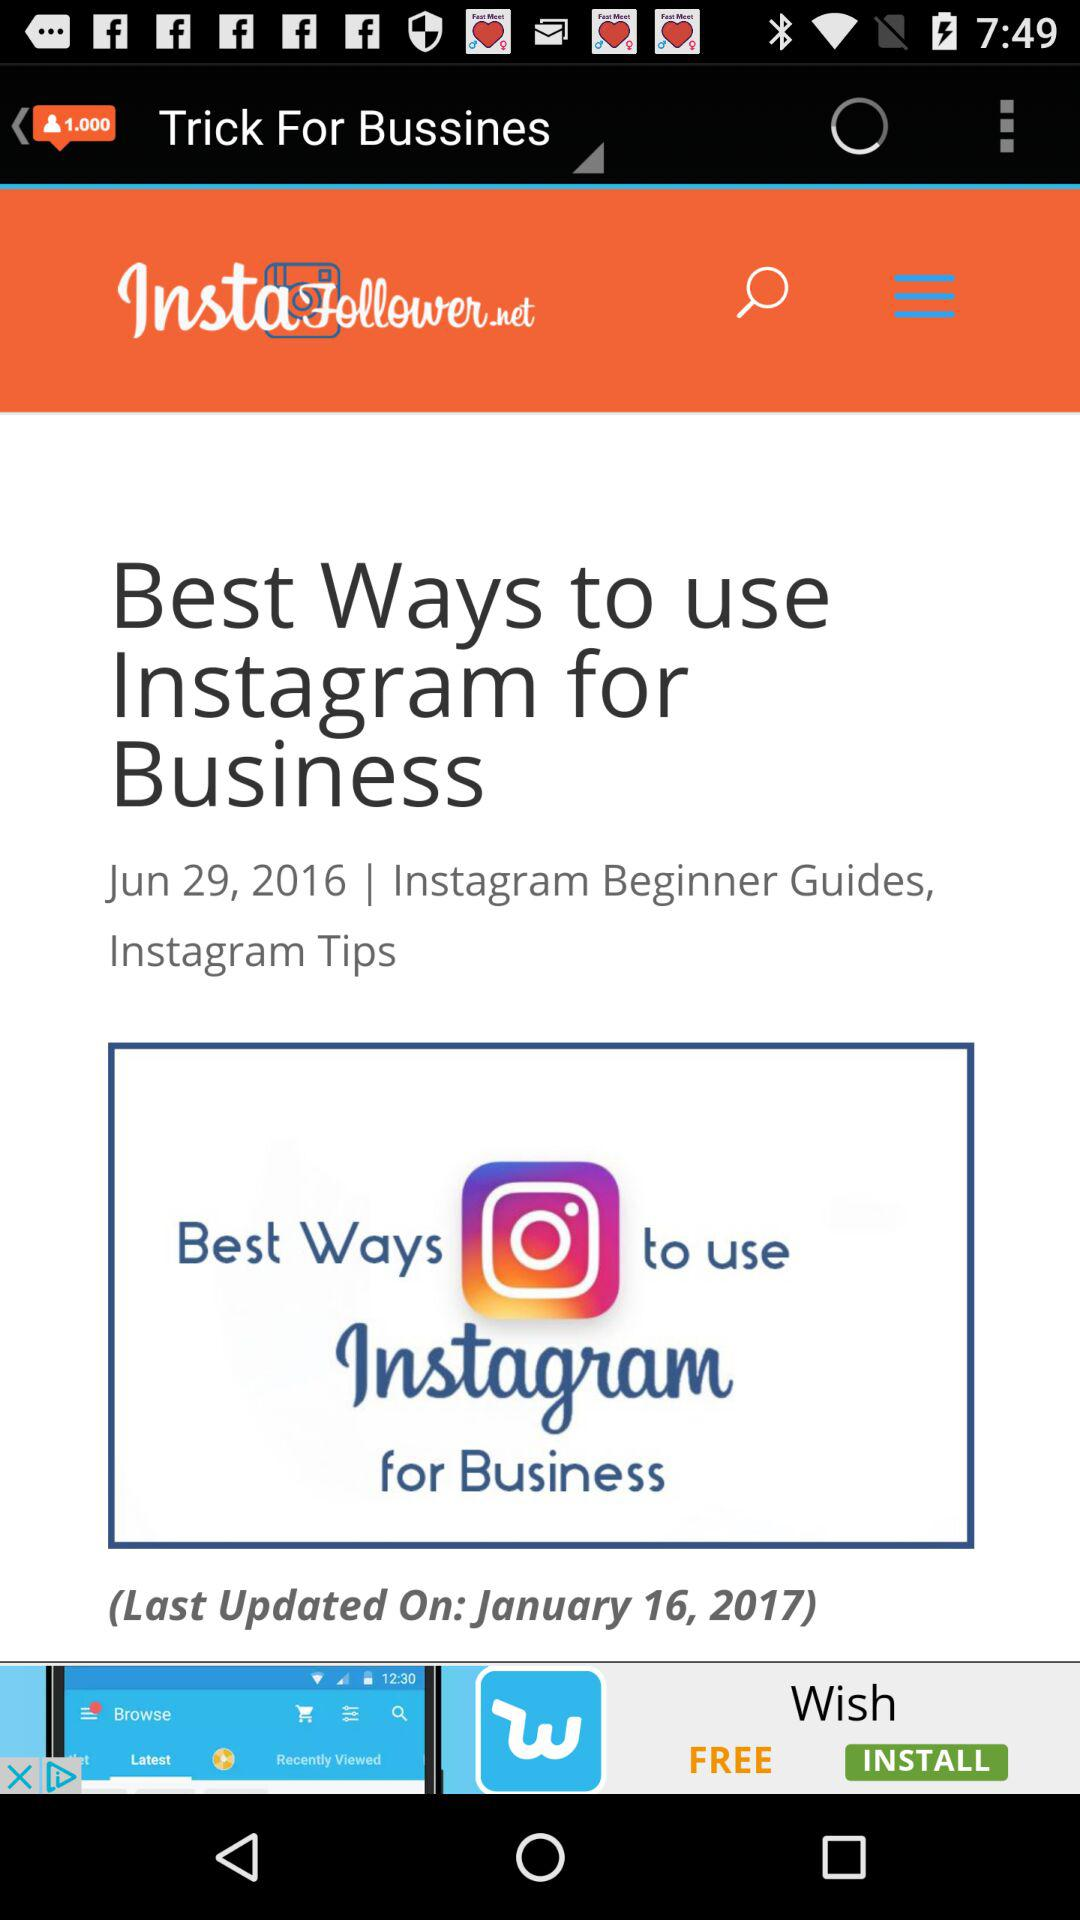When was the article last updated? The article was last updated on January 16, 2017. 